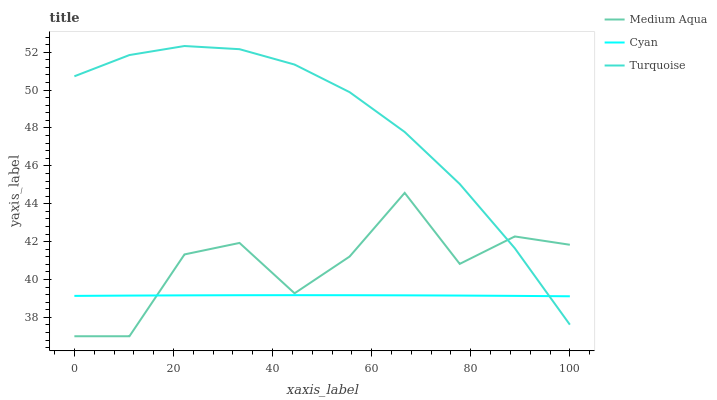Does Cyan have the minimum area under the curve?
Answer yes or no. Yes. Does Turquoise have the maximum area under the curve?
Answer yes or no. Yes. Does Medium Aqua have the minimum area under the curve?
Answer yes or no. No. Does Medium Aqua have the maximum area under the curve?
Answer yes or no. No. Is Cyan the smoothest?
Answer yes or no. Yes. Is Medium Aqua the roughest?
Answer yes or no. Yes. Is Turquoise the smoothest?
Answer yes or no. No. Is Turquoise the roughest?
Answer yes or no. No. Does Medium Aqua have the lowest value?
Answer yes or no. Yes. Does Turquoise have the lowest value?
Answer yes or no. No. Does Turquoise have the highest value?
Answer yes or no. Yes. Does Medium Aqua have the highest value?
Answer yes or no. No. Does Cyan intersect Turquoise?
Answer yes or no. Yes. Is Cyan less than Turquoise?
Answer yes or no. No. Is Cyan greater than Turquoise?
Answer yes or no. No. 